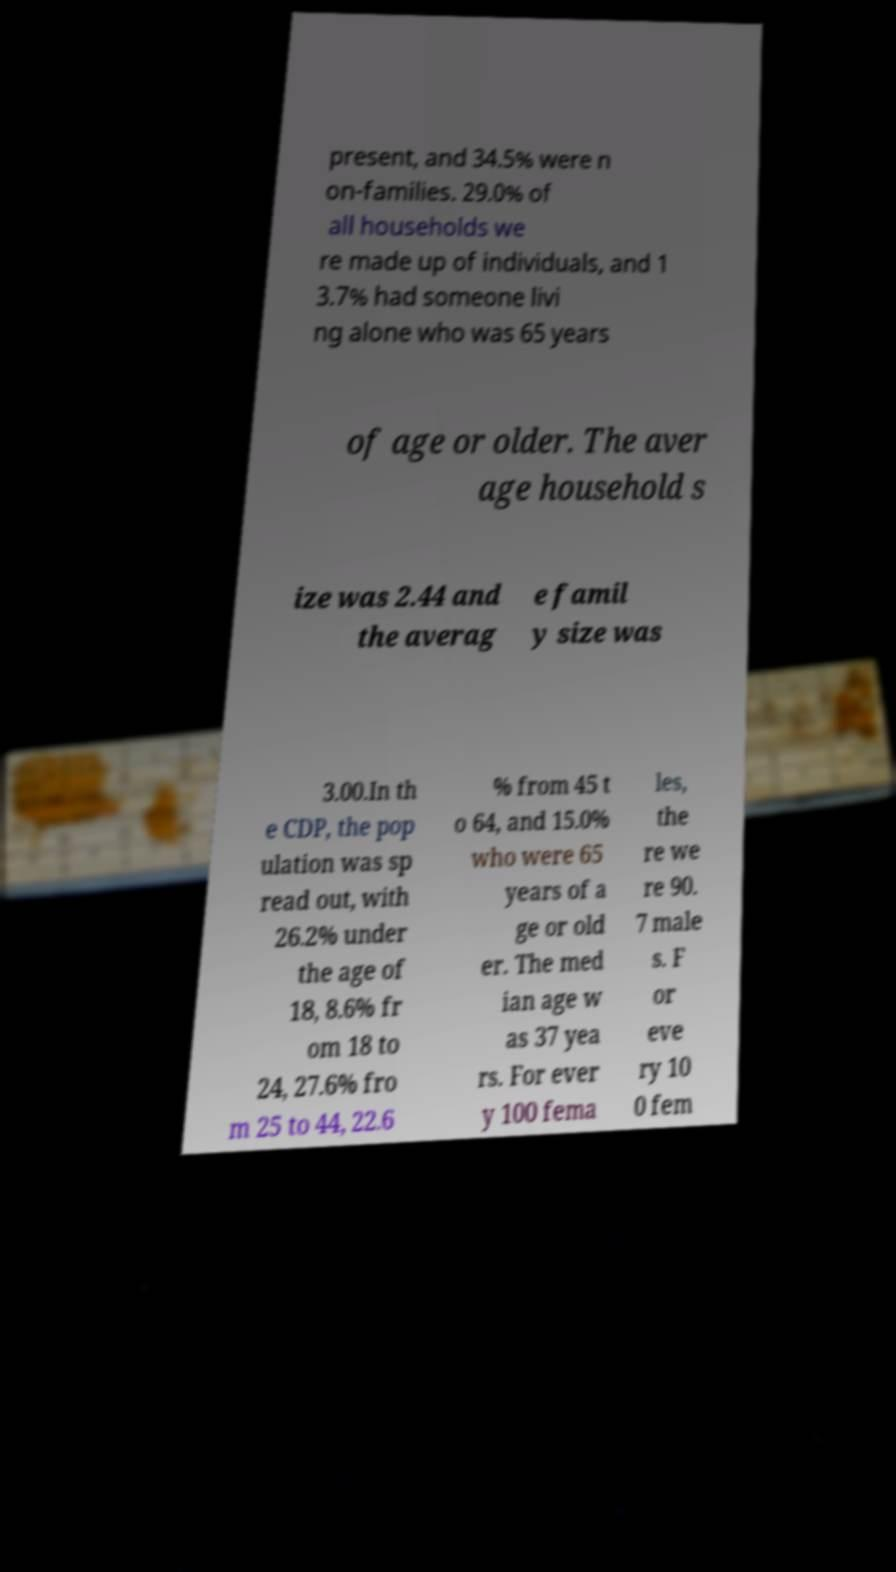For documentation purposes, I need the text within this image transcribed. Could you provide that? present, and 34.5% were n on-families. 29.0% of all households we re made up of individuals, and 1 3.7% had someone livi ng alone who was 65 years of age or older. The aver age household s ize was 2.44 and the averag e famil y size was 3.00.In th e CDP, the pop ulation was sp read out, with 26.2% under the age of 18, 8.6% fr om 18 to 24, 27.6% fro m 25 to 44, 22.6 % from 45 t o 64, and 15.0% who were 65 years of a ge or old er. The med ian age w as 37 yea rs. For ever y 100 fema les, the re we re 90. 7 male s. F or eve ry 10 0 fem 